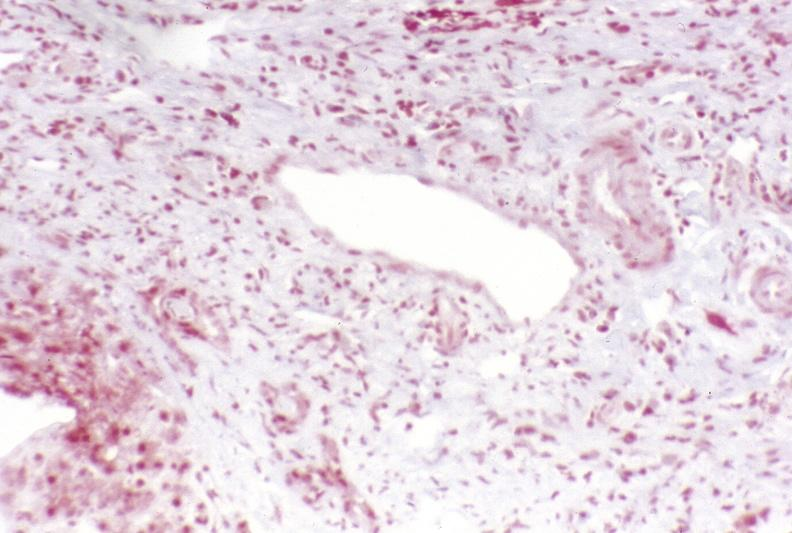s exposure present?
Answer the question using a single word or phrase. No 